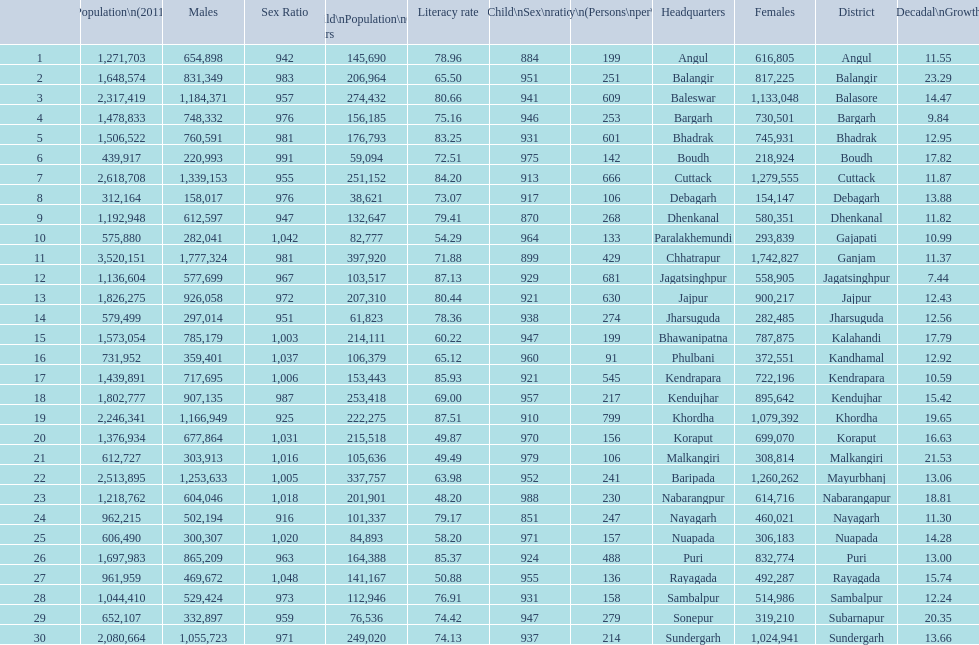Tell me a district that did not have a population over 600,000. Boudh. 